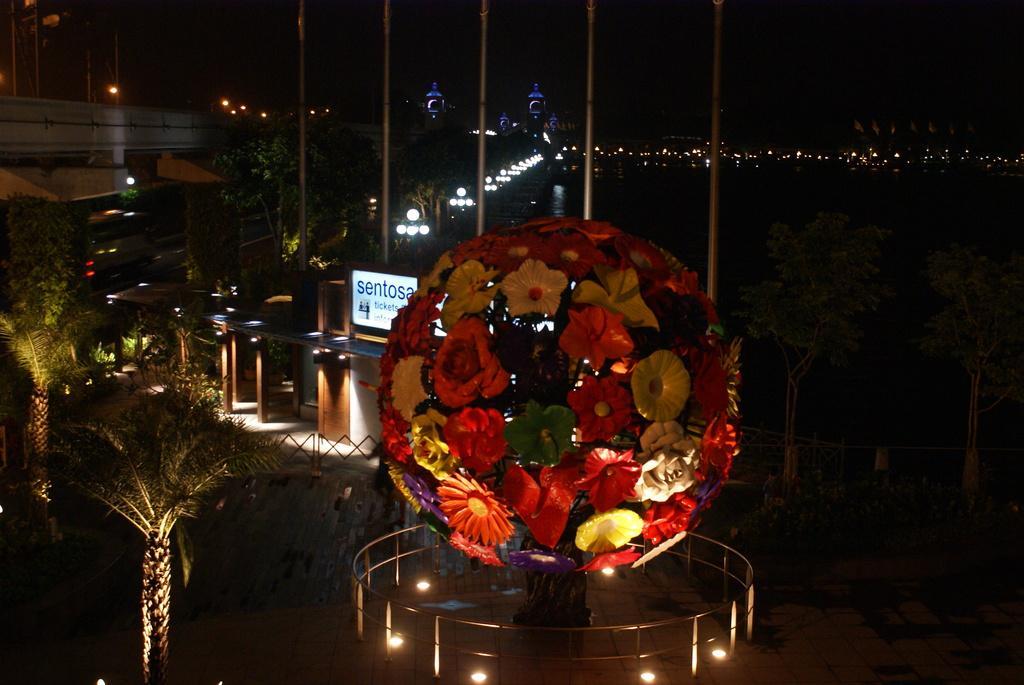Can you describe this image briefly? In the foreground of this image, there is an artificial tree like structure and railing around it. We can also see trees and few buildings. In the dark background, it seems like a building, lights and the dark sky. 